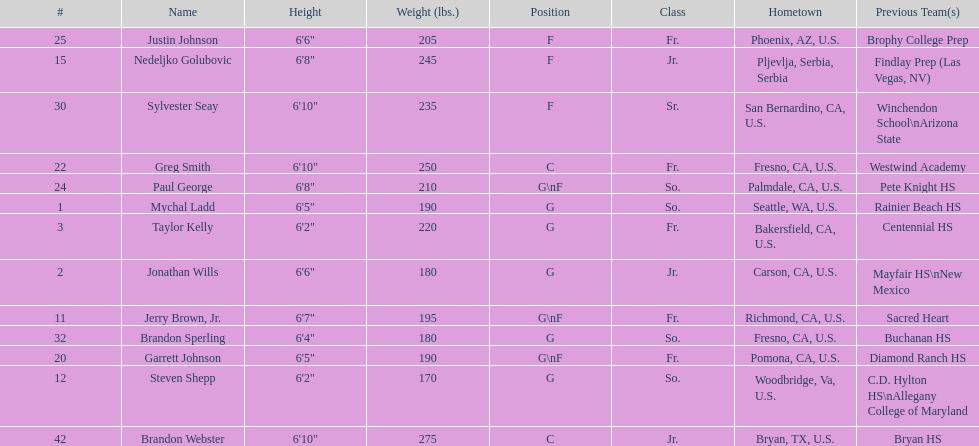Who is the next heaviest player after nedelijko golubovic? Sylvester Seay. 